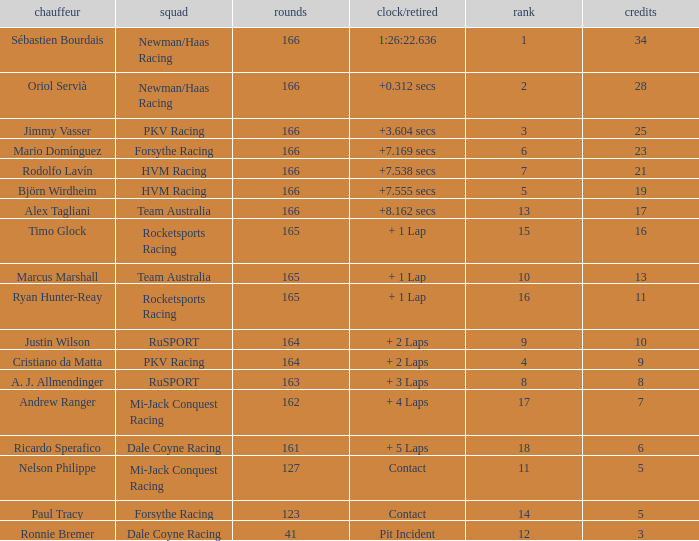What is the name of the driver with 6 points? Ricardo Sperafico. 